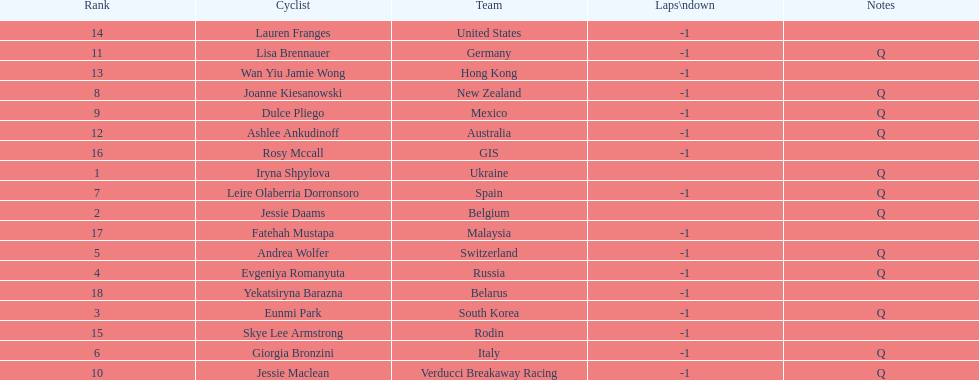Who was the first competitor to finish the race a lap behind? Eunmi Park. 